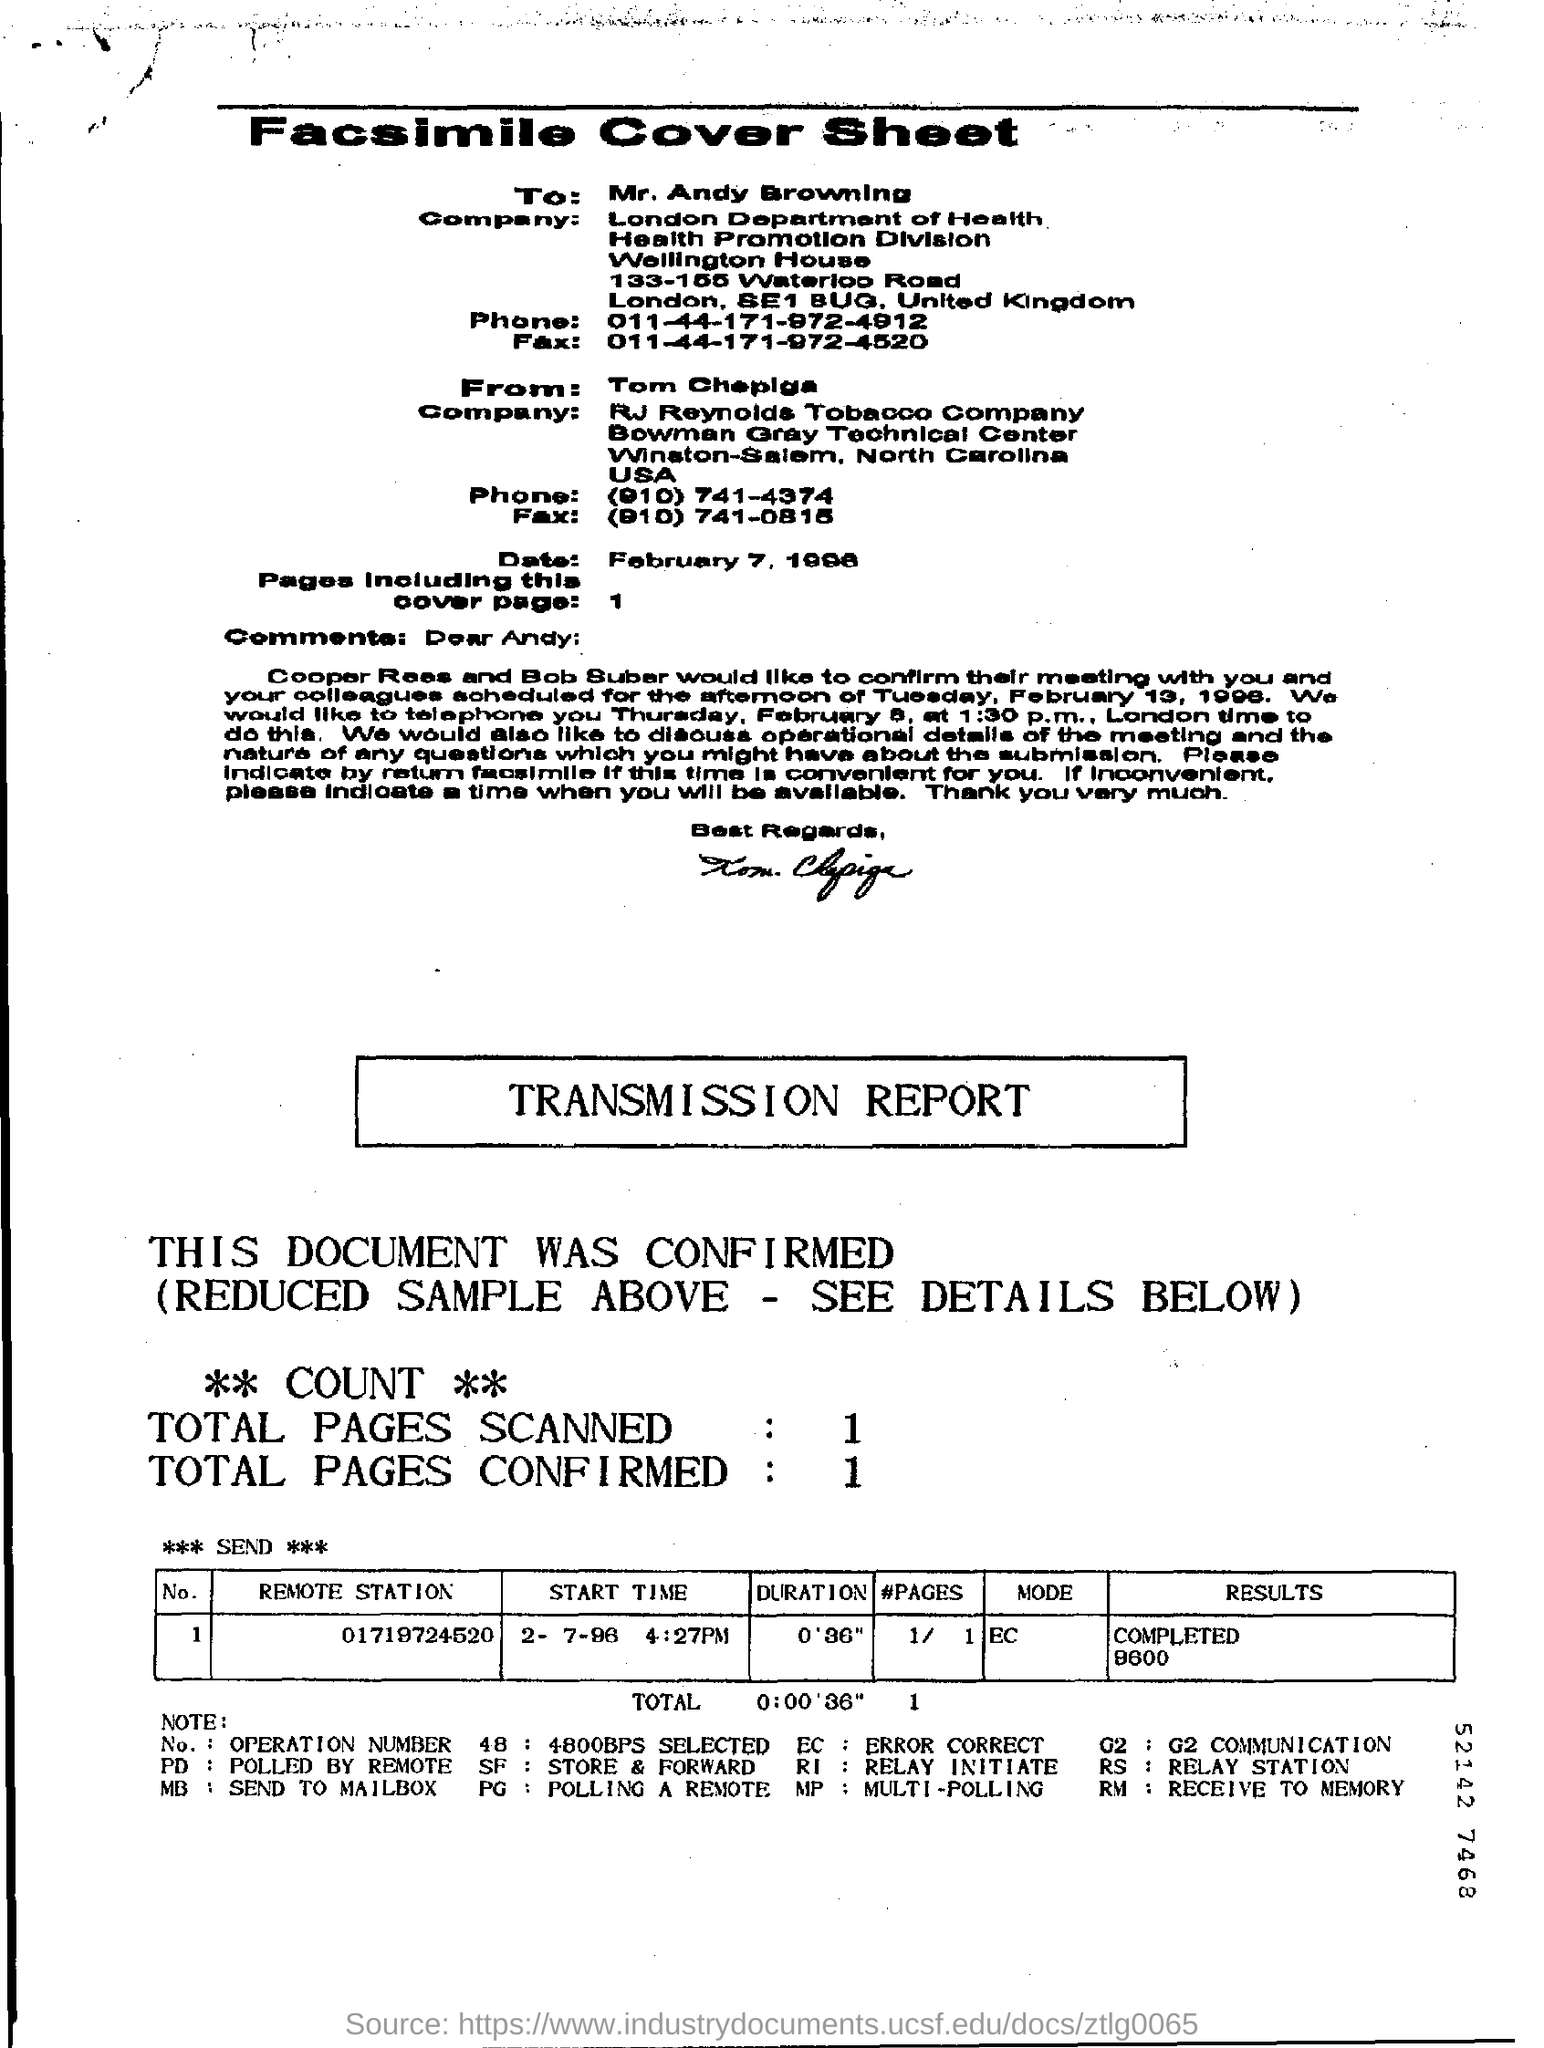What is the company name of the tom chepiga ?
Offer a terse response. RJ Reynolds Tobacco Company. What is the number of the remote station?
Provide a succinct answer. 01719724520. What is the duration in the transmission report?
Offer a terse response. 0'36". 